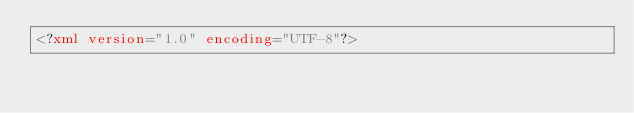<code> <loc_0><loc_0><loc_500><loc_500><_XML_><?xml version="1.0" encoding="UTF-8"?></code> 